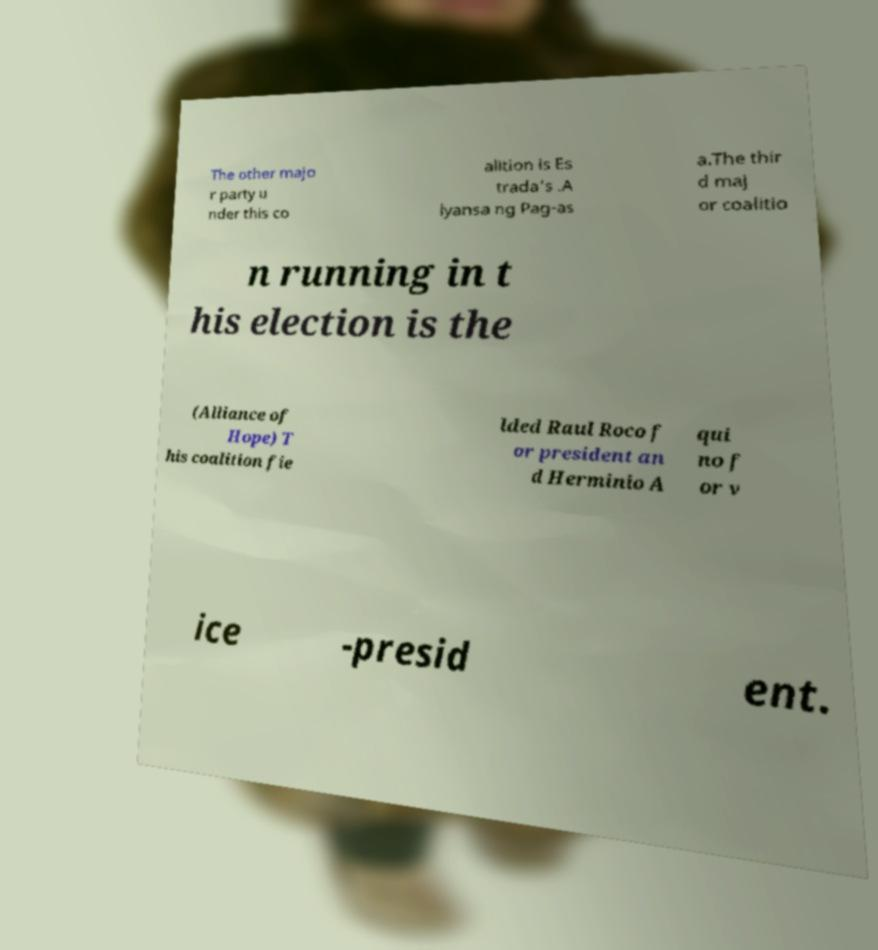Please read and relay the text visible in this image. What does it say? The other majo r party u nder this co alition is Es trada's .A lyansa ng Pag-as a.The thir d maj or coalitio n running in t his election is the (Alliance of Hope) T his coalition fie lded Raul Roco f or president an d Herminio A qui no f or v ice -presid ent. 